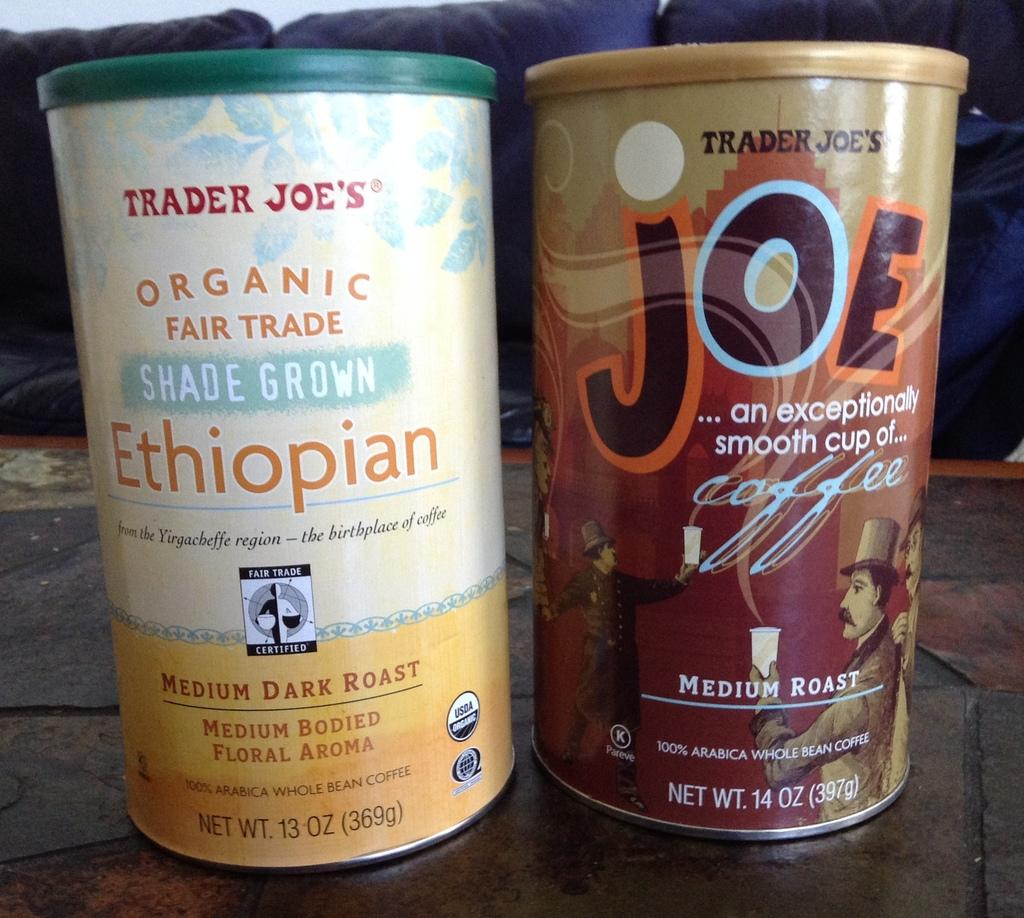Provide a one-sentence caption for the provided image. two Trader Joe's coffee products, one is Organic Fair Trade worthy.. 